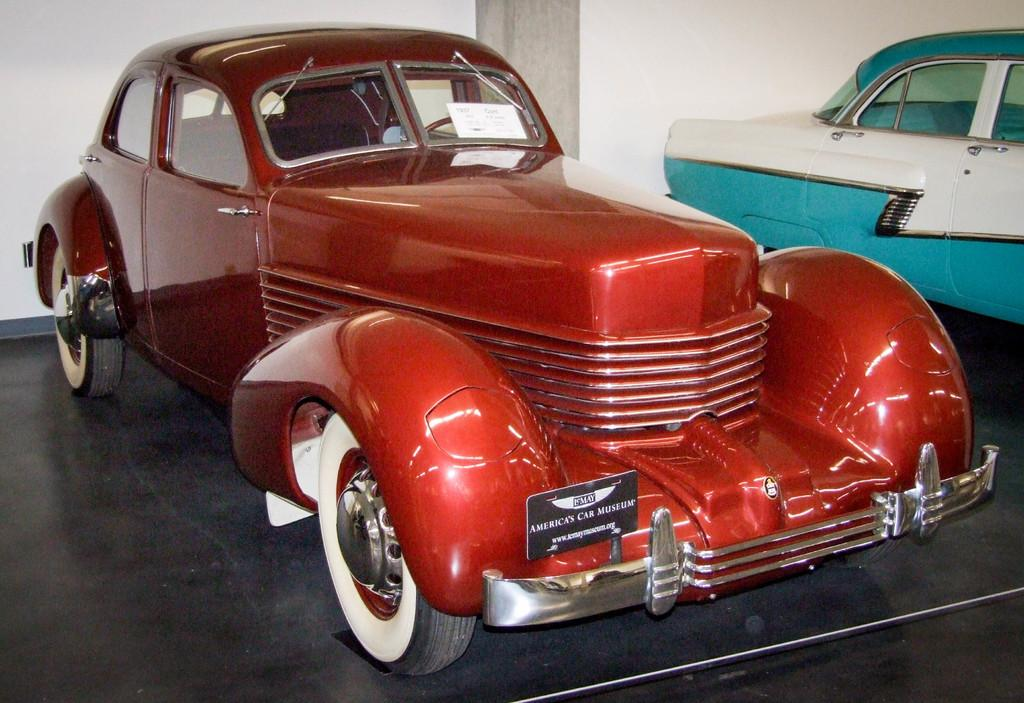How many cars are present in the image? There are two cars in the image. What else can be seen in the image besides the cars? There is a note with text in the image. What type of cream is being used to clean the monkey in the image? There is no monkey or cream present in the image. What type of soap is being used to wash the cars in the image? There is no soap mentioned or visible in the image. 